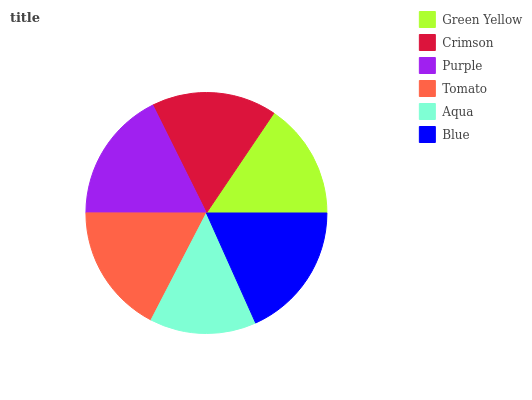Is Aqua the minimum?
Answer yes or no. Yes. Is Blue the maximum?
Answer yes or no. Yes. Is Crimson the minimum?
Answer yes or no. No. Is Crimson the maximum?
Answer yes or no. No. Is Crimson greater than Green Yellow?
Answer yes or no. Yes. Is Green Yellow less than Crimson?
Answer yes or no. Yes. Is Green Yellow greater than Crimson?
Answer yes or no. No. Is Crimson less than Green Yellow?
Answer yes or no. No. Is Tomato the high median?
Answer yes or no. Yes. Is Crimson the low median?
Answer yes or no. Yes. Is Purple the high median?
Answer yes or no. No. Is Aqua the low median?
Answer yes or no. No. 